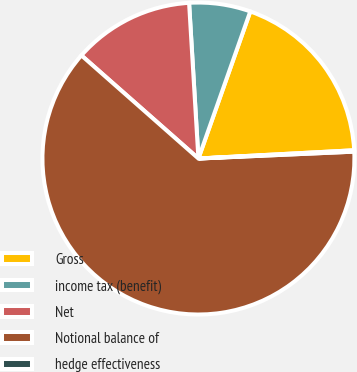Convert chart. <chart><loc_0><loc_0><loc_500><loc_500><pie_chart><fcel>Gross<fcel>income tax (benefit)<fcel>Net<fcel>Notional balance of<fcel>hedge effectiveness<nl><fcel>18.76%<fcel>6.35%<fcel>12.55%<fcel>62.2%<fcel>0.14%<nl></chart> 